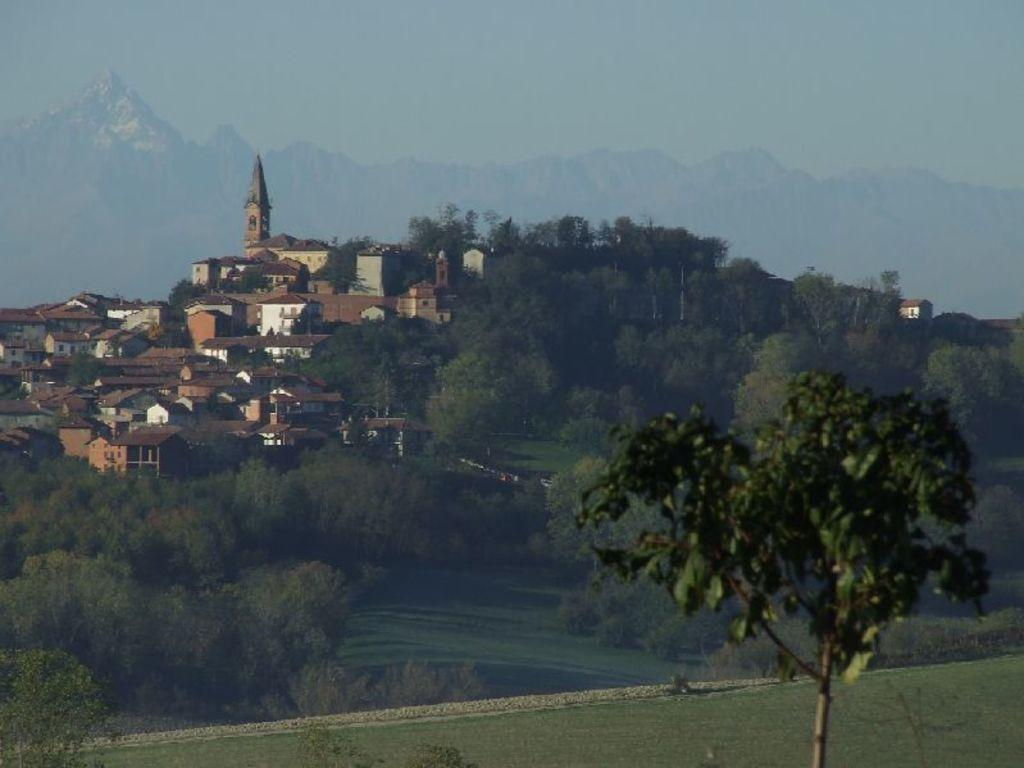What type of structures are located on the left side of the image? There are houses on the left side of the image. What type of vegetation can be seen in the image? There are trees in the image. What can be seen in the distance in the image? There are hills visible in the background of the image. What is visible above the houses and trees in the image? The sky is visible in the background of the image. Can you see a cap on top of the trees in the image? There is no cap present on top of the trees in the image. Is the person referred to as "dad" visible in the image? There is no person referred to as "dad" mentioned in the provided facts, so it cannot be determined if they are visible in the image. 